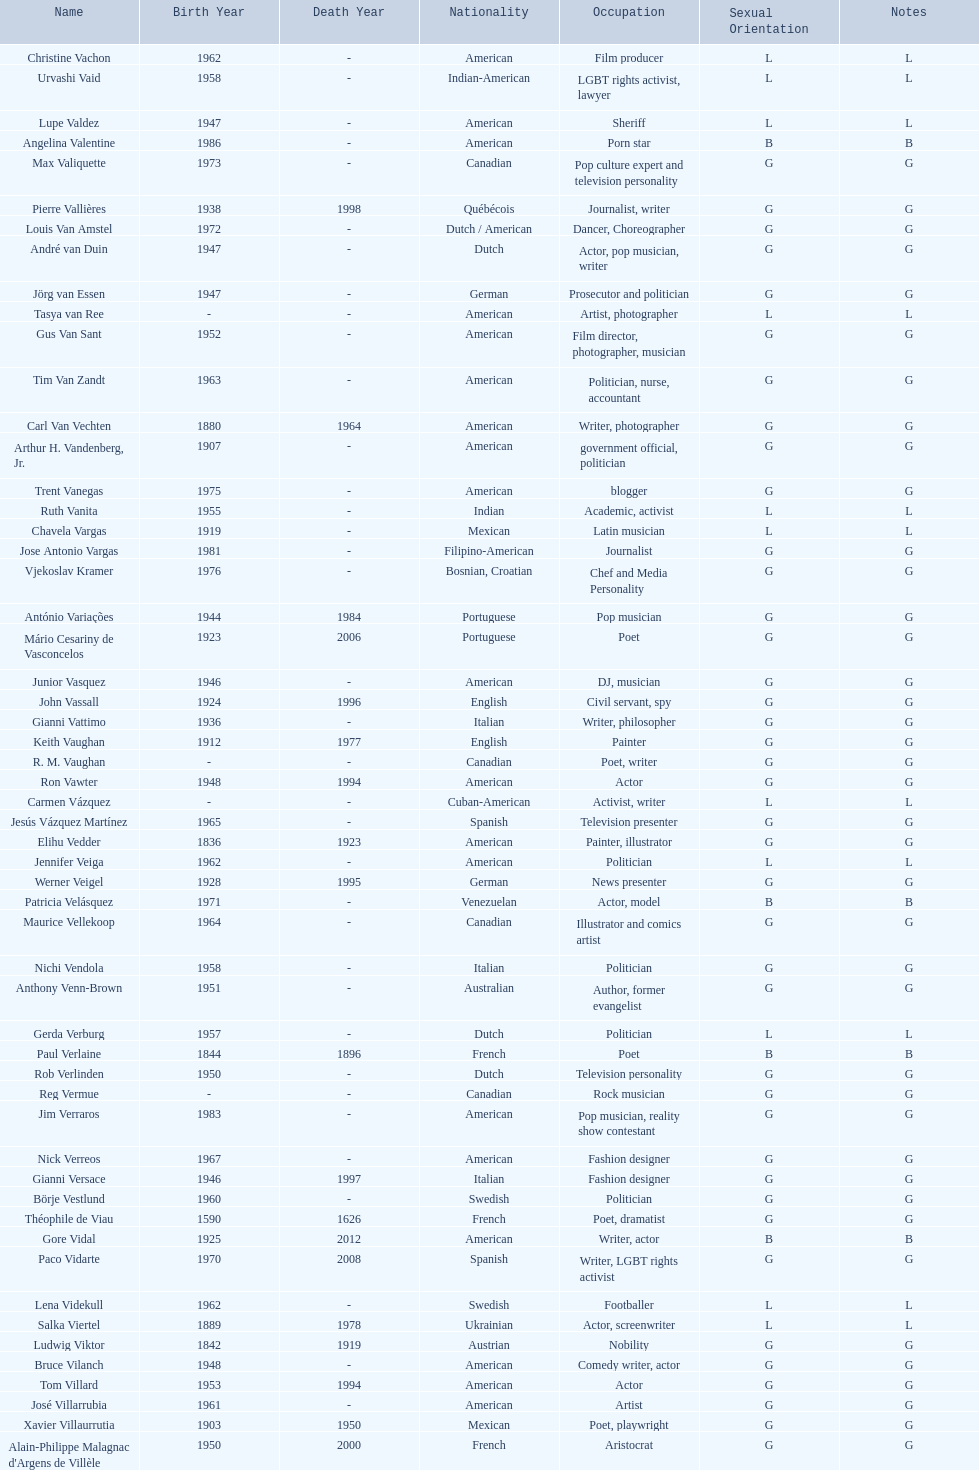Who was canadian, van amstel or valiquette? Valiquette. 